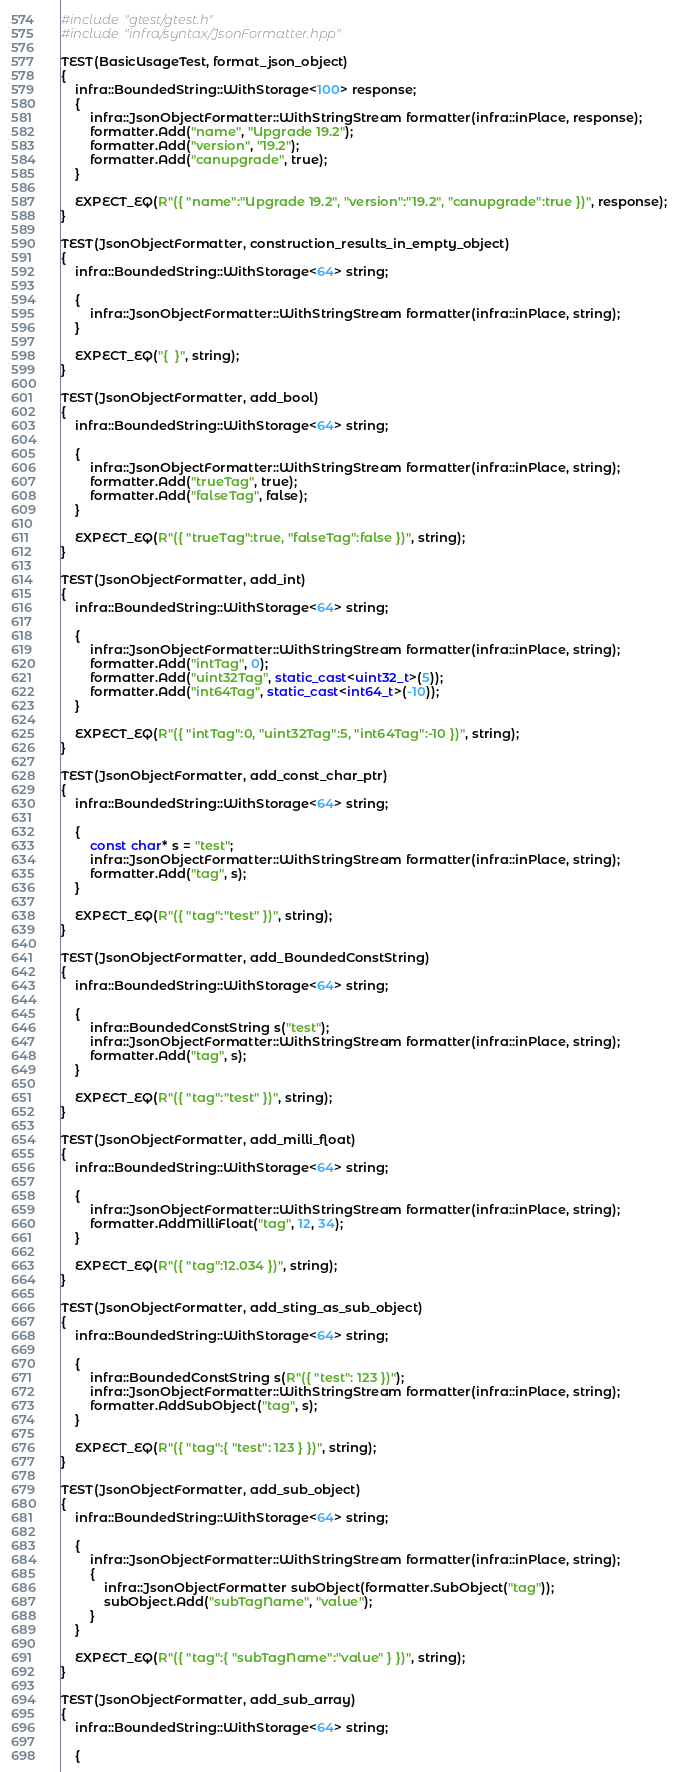Convert code to text. <code><loc_0><loc_0><loc_500><loc_500><_C++_>#include "gtest/gtest.h"
#include "infra/syntax/JsonFormatter.hpp"

TEST(BasicUsageTest, format_json_object)
{
    infra::BoundedString::WithStorage<100> response;
    {
        infra::JsonObjectFormatter::WithStringStream formatter(infra::inPlace, response);
        formatter.Add("name", "Upgrade 19.2");
        formatter.Add("version", "19.2");
        formatter.Add("canupgrade", true);
    }

    EXPECT_EQ(R"({ "name":"Upgrade 19.2", "version":"19.2", "canupgrade":true })", response);
}

TEST(JsonObjectFormatter, construction_results_in_empty_object)
{
    infra::BoundedString::WithStorage<64> string;

    {
        infra::JsonObjectFormatter::WithStringStream formatter(infra::inPlace, string);
    }

    EXPECT_EQ("{  }", string);
}

TEST(JsonObjectFormatter, add_bool)
{
    infra::BoundedString::WithStorage<64> string;

    {
        infra::JsonObjectFormatter::WithStringStream formatter(infra::inPlace, string);
        formatter.Add("trueTag", true);
        formatter.Add("falseTag", false);
    }

    EXPECT_EQ(R"({ "trueTag":true, "falseTag":false })", string);
}

TEST(JsonObjectFormatter, add_int)
{
    infra::BoundedString::WithStorage<64> string;

    {
        infra::JsonObjectFormatter::WithStringStream formatter(infra::inPlace, string);
        formatter.Add("intTag", 0);
        formatter.Add("uint32Tag", static_cast<uint32_t>(5));
        formatter.Add("int64Tag", static_cast<int64_t>(-10));
    }

    EXPECT_EQ(R"({ "intTag":0, "uint32Tag":5, "int64Tag":-10 })", string);
}

TEST(JsonObjectFormatter, add_const_char_ptr)
{
    infra::BoundedString::WithStorage<64> string;

    {
        const char* s = "test";
        infra::JsonObjectFormatter::WithStringStream formatter(infra::inPlace, string);
        formatter.Add("tag", s);
    }

    EXPECT_EQ(R"({ "tag":"test" })", string);
}

TEST(JsonObjectFormatter, add_BoundedConstString)
{
    infra::BoundedString::WithStorage<64> string;

    {
        infra::BoundedConstString s("test");
        infra::JsonObjectFormatter::WithStringStream formatter(infra::inPlace, string);
        formatter.Add("tag", s);
    }

    EXPECT_EQ(R"({ "tag":"test" })", string);
}

TEST(JsonObjectFormatter, add_milli_float)
{
    infra::BoundedString::WithStorage<64> string;

    {
        infra::JsonObjectFormatter::WithStringStream formatter(infra::inPlace, string);
        formatter.AddMilliFloat("tag", 12, 34);
    }

    EXPECT_EQ(R"({ "tag":12.034 })", string);
}

TEST(JsonObjectFormatter, add_sting_as_sub_object)
{
    infra::BoundedString::WithStorage<64> string;

    {
        infra::BoundedConstString s(R"({ "test": 123 })");
        infra::JsonObjectFormatter::WithStringStream formatter(infra::inPlace, string);
        formatter.AddSubObject("tag", s);
    }

    EXPECT_EQ(R"({ "tag":{ "test": 123 } })", string);
}

TEST(JsonObjectFormatter, add_sub_object)
{
    infra::BoundedString::WithStorage<64> string;

    {
        infra::JsonObjectFormatter::WithStringStream formatter(infra::inPlace, string);
        {
            infra::JsonObjectFormatter subObject(formatter.SubObject("tag"));
            subObject.Add("subTagName", "value");
        }
    }

    EXPECT_EQ(R"({ "tag":{ "subTagName":"value" } })", string);
}

TEST(JsonObjectFormatter, add_sub_array)
{
    infra::BoundedString::WithStorage<64> string;

    {</code> 